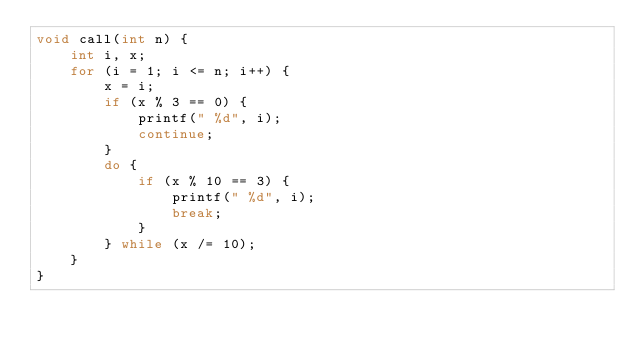Convert code to text. <code><loc_0><loc_0><loc_500><loc_500><_C_>void call(int n) {
    int i, x;
    for (i = 1; i <= n; i++) {
        x = i;
        if (x % 3 == 0) {
            printf(" %d", i);
            continue;
        }
        do {
            if (x % 10 == 3) {
                printf(" %d", i);
                break;
            }
        } while (x /= 10);
    }
}</code> 